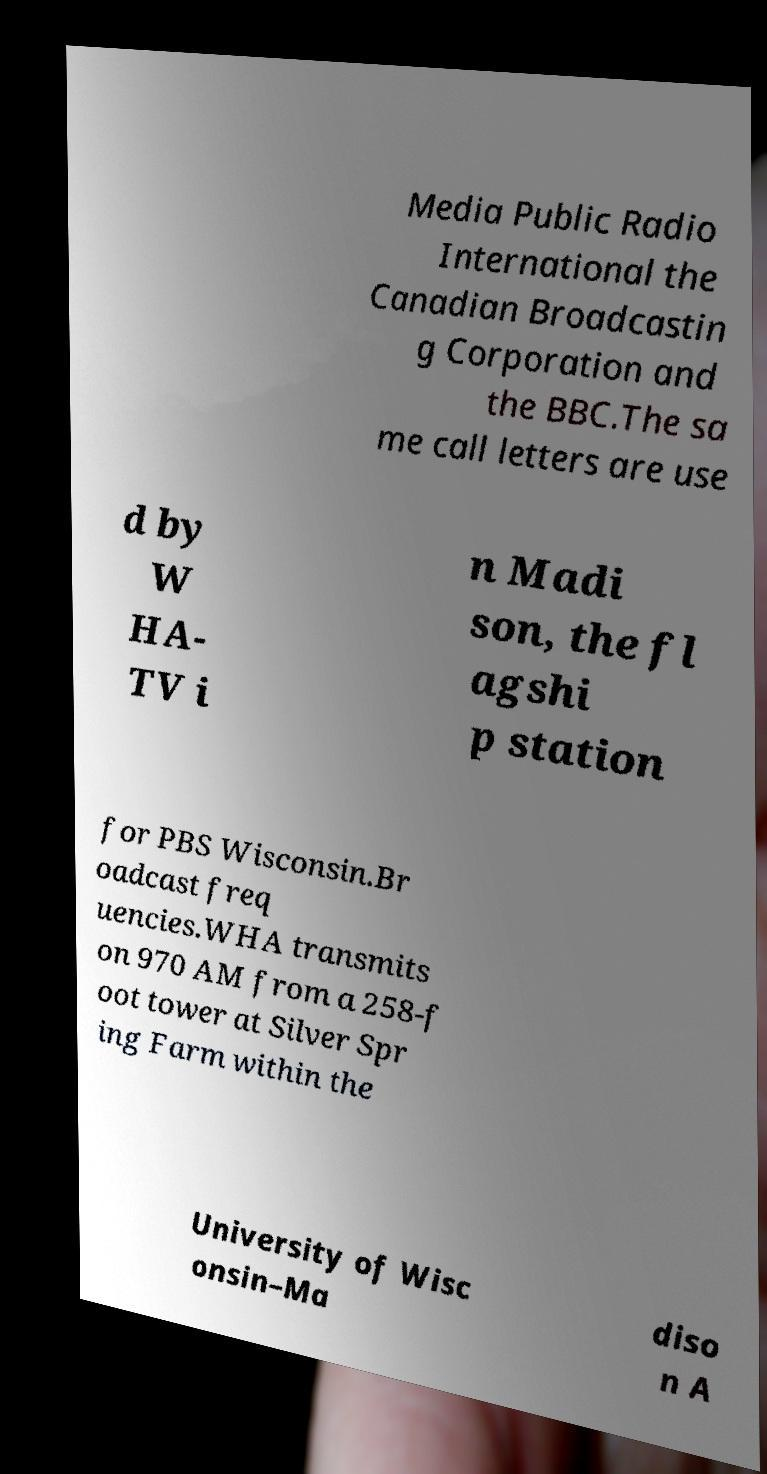For documentation purposes, I need the text within this image transcribed. Could you provide that? Media Public Radio International the Canadian Broadcastin g Corporation and the BBC.The sa me call letters are use d by W HA- TV i n Madi son, the fl agshi p station for PBS Wisconsin.Br oadcast freq uencies.WHA transmits on 970 AM from a 258-f oot tower at Silver Spr ing Farm within the University of Wisc onsin–Ma diso n A 